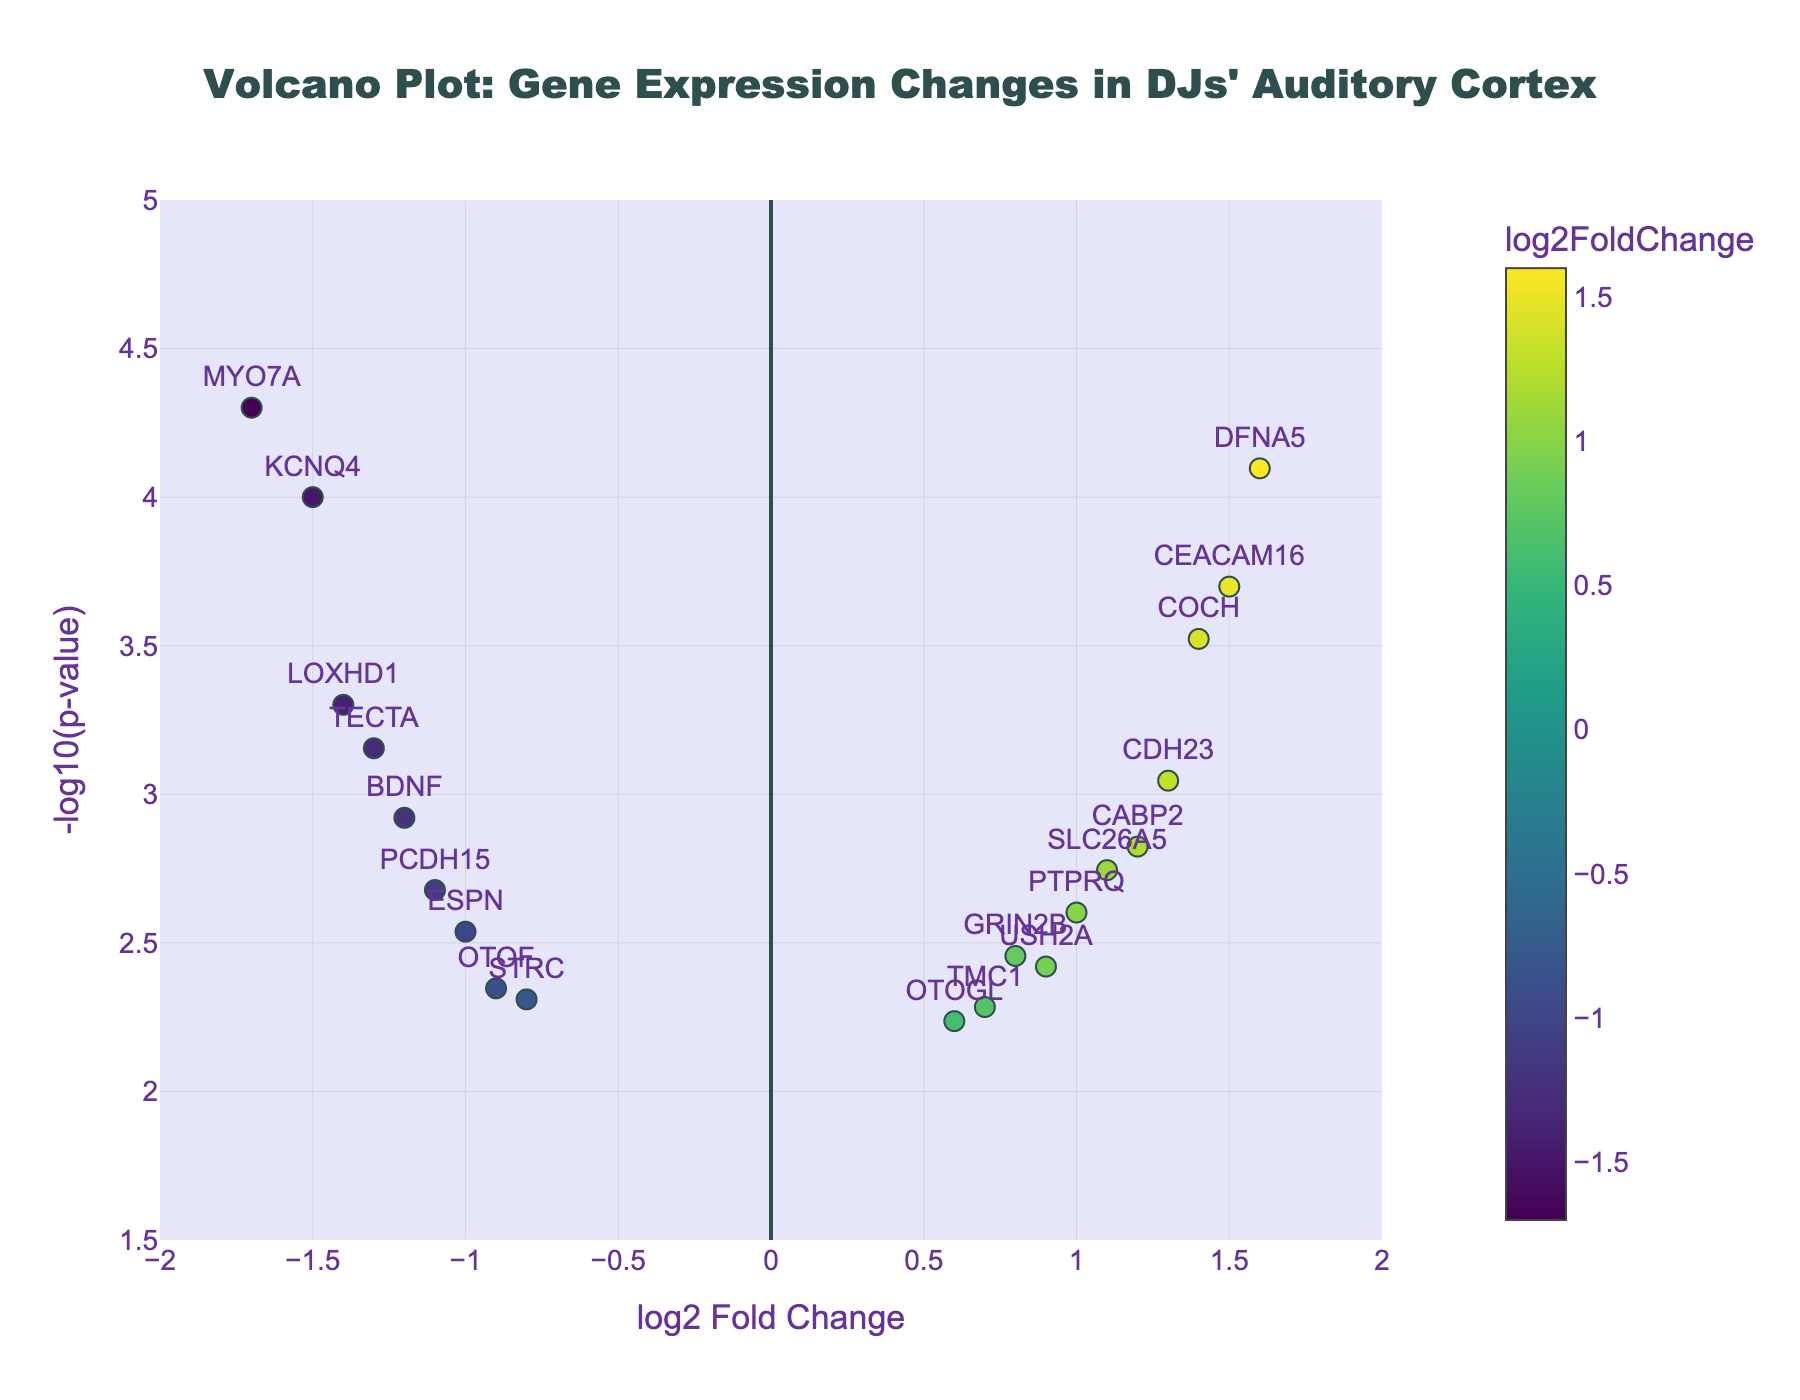How many genes are plotted in the figure? Count the number of distinct data points in the plot. Each gene is represented by a separate point.
Answer: 20 What is the title of the figure? The title is prominently displayed at the top of the figure in the center.
Answer: Volcano Plot: Gene Expression Changes in DJs' Auditory Cortex Which gene has the highest -log10(p-value)? Identify the point with the maximum y-axis value and read the associated gene label.
Answer: MYO7A Which gene has the largest positive log2 fold change? Identify the point furthest to the right on the x-axis and read the associated gene label.
Answer: DFNA5 Which gene has the smallest p-value? The smallest p-value corresponds to the highest -log10(p-value). Identify the gene with the maximum y-axis value.
Answer: MYO7A What is the log2 fold change and p-value for the gene DFNA5? Locate the point for DFNA5, then read its x-axis (log2 fold change) and y-axis (-log10(p-value)) values. Convert the y-axis value back to p-value using 10^(-y-axis value).
Answer: log2FC: 1.6, p-value: 0.00008 How many genes have a negative log2 fold change? Count the points to the left of the y-axis (x < 0).
Answer: 9 Which gene has a log2 fold change of approximately -1.2? Identify the point around x = -1.2 and read the associated gene label.
Answer: BDNF How many genes have a -log10(p-value) greater than 3? Count the points above y = 3 on the y-axis.
Answer: 10 Which gene with a positive log2 fold change has the smallest p-value? Among the points with x > 0, find the one with the highest y-axis value and read the associated gene label.
Answer: DFNA5 